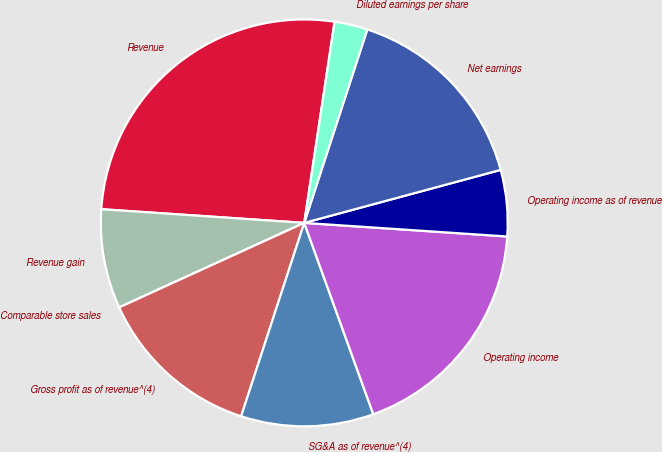Convert chart to OTSL. <chart><loc_0><loc_0><loc_500><loc_500><pie_chart><fcel>Revenue<fcel>Revenue gain<fcel>Comparable store sales<fcel>Gross profit as of revenue^(4)<fcel>SG&A as of revenue^(4)<fcel>Operating income<fcel>Operating income as of revenue<fcel>Net earnings<fcel>Diluted earnings per share<nl><fcel>26.31%<fcel>7.89%<fcel>0.0%<fcel>13.16%<fcel>10.53%<fcel>18.42%<fcel>5.26%<fcel>15.79%<fcel>2.63%<nl></chart> 